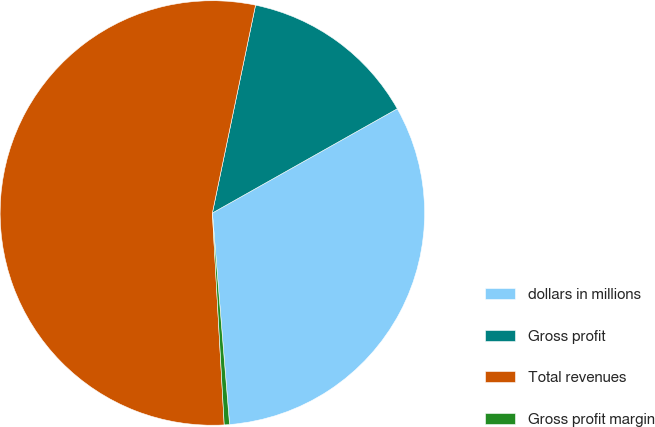Convert chart. <chart><loc_0><loc_0><loc_500><loc_500><pie_chart><fcel>dollars in millions<fcel>Gross profit<fcel>Total revenues<fcel>Gross profit margin<nl><fcel>31.88%<fcel>13.57%<fcel>54.15%<fcel>0.4%<nl></chart> 